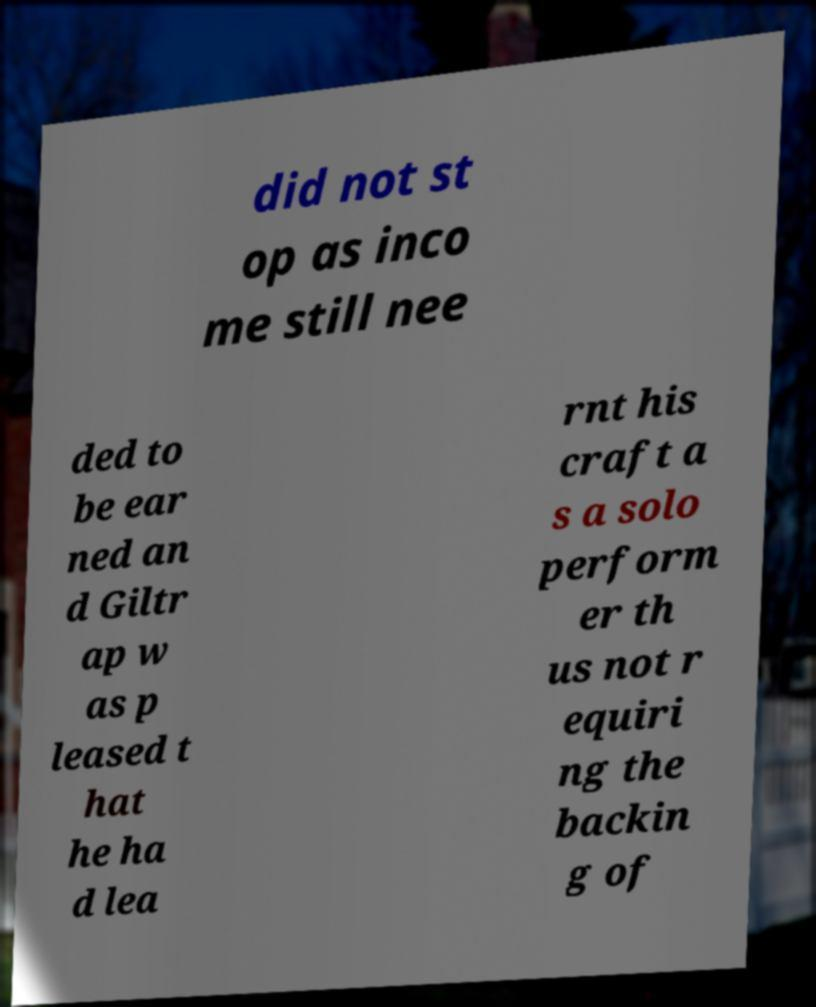Can you accurately transcribe the text from the provided image for me? did not st op as inco me still nee ded to be ear ned an d Giltr ap w as p leased t hat he ha d lea rnt his craft a s a solo perform er th us not r equiri ng the backin g of 